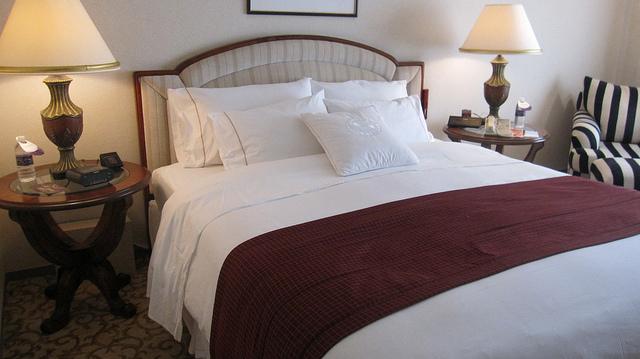How many lamps are there?
Keep it brief. 2. Is the bed neat?
Answer briefly. Yes. What pattern is the chair?
Write a very short answer. Striped. 